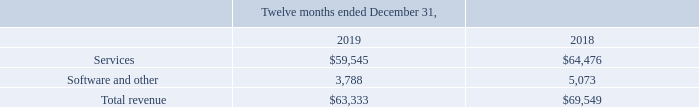Disaggregation of Revenue
We generate revenue from the sale of services and sale of software for end-user software products provided through direct customer downloads and through the sale of these end-user software products via partners. The following table depicts the disaggregation of revenue (in thousands) according to revenue type and is consistent with how we evaluate our financial performance:
Revenue from Contracts with Customers:
In which years was the revenue from contracts with customers recorded for? 2019, 2018. How does the company create revenue? From the sale of services and sale of software for end-user software products provided through direct customer downloads and through the sale of these end-user software products via partners. What was the revenue from services in 2018?
Answer scale should be: thousand. $64,476. Which year was the software and other revenue higher? 5,073 > 3,788
Answer: 2018. What was the change in services revenue between 2018 and 2019?
Answer scale should be: thousand. $59,545 - $64,476 
Answer: -4931. What was the percentage change in total revenue between 2018 and 2019?
Answer scale should be: percent. ($63,333 - $69,549)/$69,549 
Answer: -8.94. 